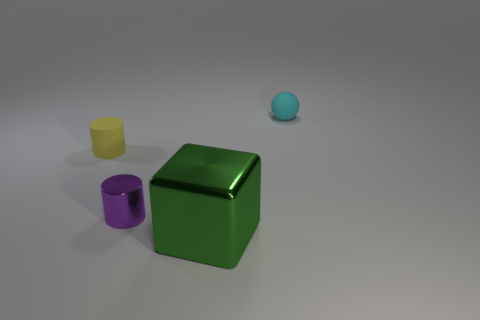Is there any other thing that is the same size as the green block?
Your response must be concise. No. How many objects are shiny blocks or tiny things that are to the left of the big object?
Keep it short and to the point. 3. There is a big shiny thing; does it have the same color as the tiny thing that is on the left side of the tiny purple metallic object?
Provide a succinct answer. No. There is a thing that is both to the right of the tiny purple shiny thing and behind the big green shiny block; what size is it?
Your response must be concise. Small. Are there any small cyan matte spheres behind the tiny matte sphere?
Offer a terse response. No. Is there a small shiny cylinder behind the tiny object behind the small yellow cylinder?
Offer a very short reply. No. Are there an equal number of yellow matte cylinders that are right of the tiny purple cylinder and purple metal things behind the green object?
Offer a very short reply. No. There is a large cube that is the same material as the tiny purple cylinder; what is its color?
Offer a terse response. Green. Are there any big things made of the same material as the tiny purple object?
Offer a very short reply. Yes. How many objects are small purple things or small yellow things?
Provide a succinct answer. 2. 